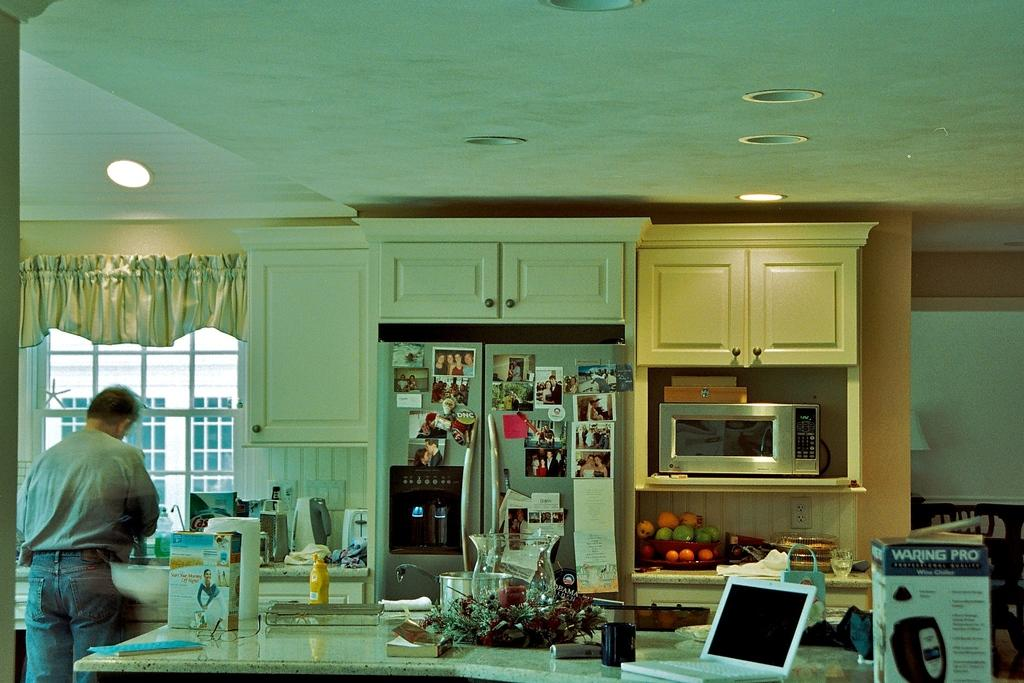<image>
Give a short and clear explanation of the subsequent image. A cluttered kitchen has a DNC button displayed among many photos and notes on the refrigerator. 